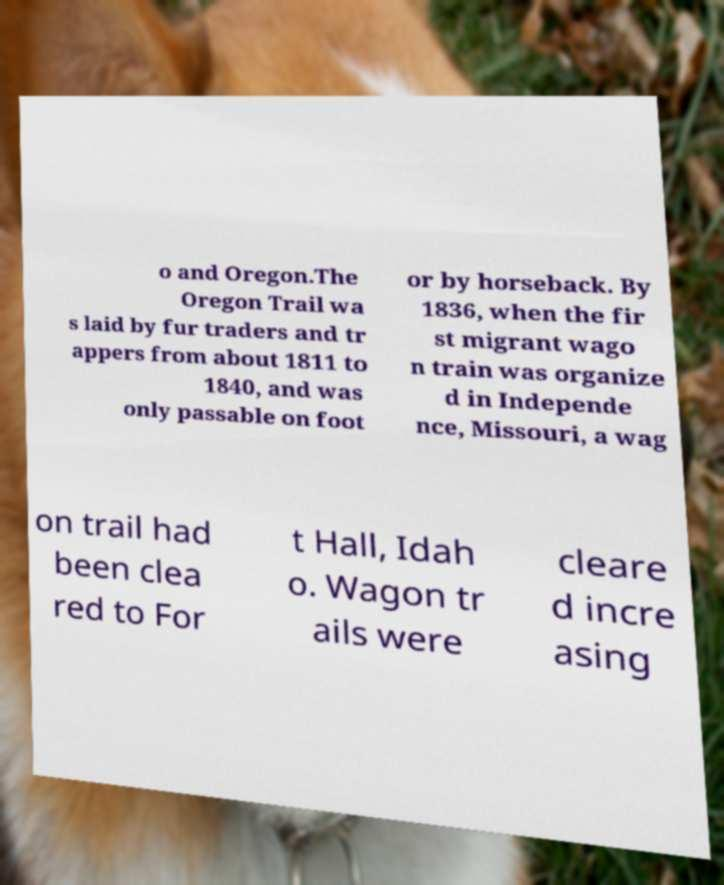Please read and relay the text visible in this image. What does it say? o and Oregon.The Oregon Trail wa s laid by fur traders and tr appers from about 1811 to 1840, and was only passable on foot or by horseback. By 1836, when the fir st migrant wago n train was organize d in Independe nce, Missouri, a wag on trail had been clea red to For t Hall, Idah o. Wagon tr ails were cleare d incre asing 